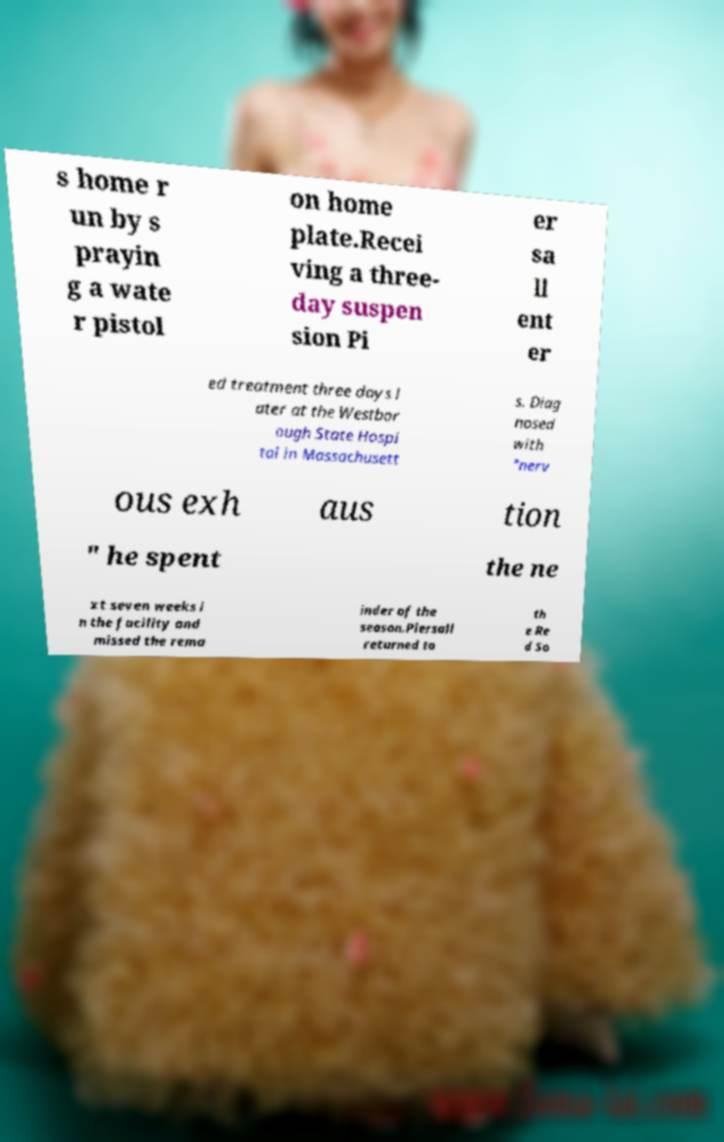Please identify and transcribe the text found in this image. s home r un by s prayin g a wate r pistol on home plate.Recei ving a three- day suspen sion Pi er sa ll ent er ed treatment three days l ater at the Westbor ough State Hospi tal in Massachusett s. Diag nosed with "nerv ous exh aus tion " he spent the ne xt seven weeks i n the facility and missed the rema inder of the season.Piersall returned to th e Re d So 